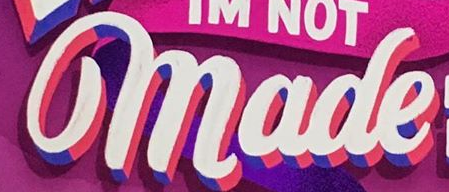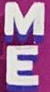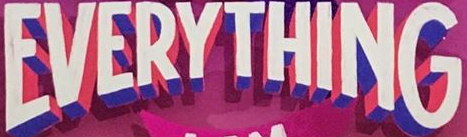Identify the words shown in these images in order, separated by a semicolon. made; ME; EVERYTHING 